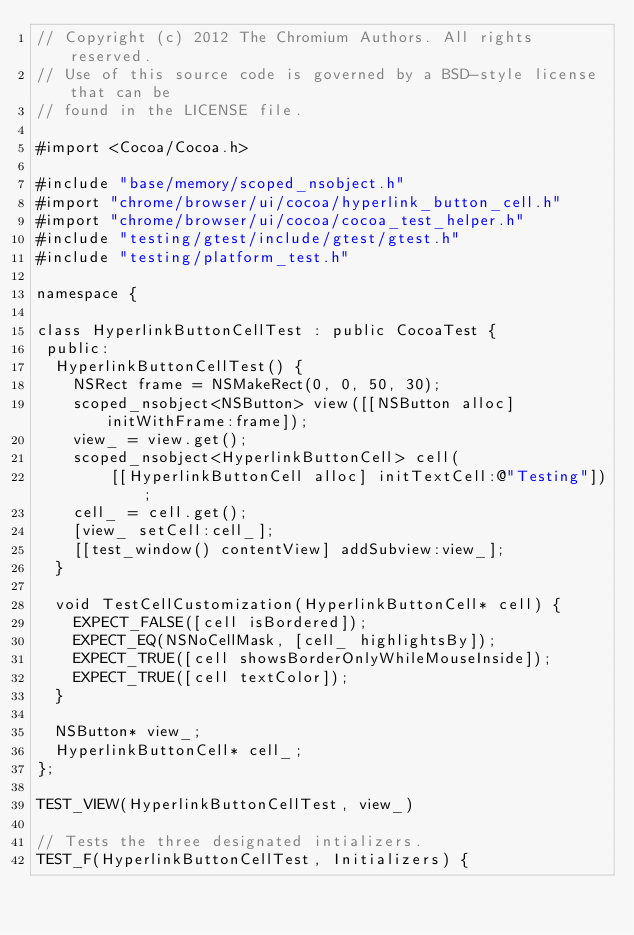Convert code to text. <code><loc_0><loc_0><loc_500><loc_500><_ObjectiveC_>// Copyright (c) 2012 The Chromium Authors. All rights reserved.
// Use of this source code is governed by a BSD-style license that can be
// found in the LICENSE file.

#import <Cocoa/Cocoa.h>

#include "base/memory/scoped_nsobject.h"
#import "chrome/browser/ui/cocoa/hyperlink_button_cell.h"
#import "chrome/browser/ui/cocoa/cocoa_test_helper.h"
#include "testing/gtest/include/gtest/gtest.h"
#include "testing/platform_test.h"

namespace {

class HyperlinkButtonCellTest : public CocoaTest {
 public:
  HyperlinkButtonCellTest() {
    NSRect frame = NSMakeRect(0, 0, 50, 30);
    scoped_nsobject<NSButton> view([[NSButton alloc] initWithFrame:frame]);
    view_ = view.get();
    scoped_nsobject<HyperlinkButtonCell> cell(
        [[HyperlinkButtonCell alloc] initTextCell:@"Testing"]);
    cell_ = cell.get();
    [view_ setCell:cell_];
    [[test_window() contentView] addSubview:view_];
  }

  void TestCellCustomization(HyperlinkButtonCell* cell) {
    EXPECT_FALSE([cell isBordered]);
    EXPECT_EQ(NSNoCellMask, [cell_ highlightsBy]);
    EXPECT_TRUE([cell showsBorderOnlyWhileMouseInside]);
    EXPECT_TRUE([cell textColor]);
  }

  NSButton* view_;
  HyperlinkButtonCell* cell_;
};

TEST_VIEW(HyperlinkButtonCellTest, view_)

// Tests the three designated intializers.
TEST_F(HyperlinkButtonCellTest, Initializers) {</code> 